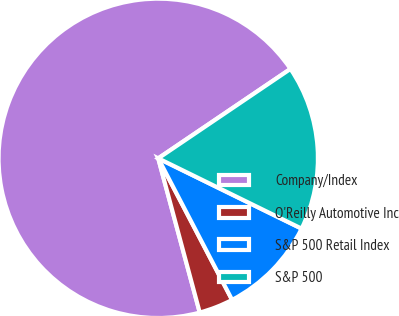Convert chart. <chart><loc_0><loc_0><loc_500><loc_500><pie_chart><fcel>Company/Index<fcel>O'Reilly Automotive Inc<fcel>S&P 500 Retail Index<fcel>S&P 500<nl><fcel>69.72%<fcel>3.47%<fcel>10.09%<fcel>16.72%<nl></chart> 